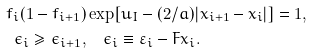Convert formula to latex. <formula><loc_0><loc_0><loc_500><loc_500>f _ { i } ( 1 - f _ { i + 1 } ) & \exp [ u _ { I } - ( 2 / a ) | x _ { i + 1 } - x _ { i } | ] = 1 , \\ \epsilon _ { i } \geq \epsilon _ { i + 1 } , & \quad \epsilon _ { i } \equiv \varepsilon _ { i } - F x _ { i } .</formula> 